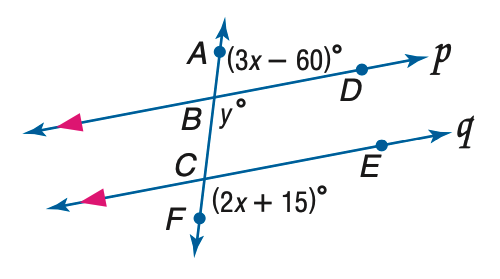Question: Refer to the figure at the right. Find the value of x if p \parallel q.
Choices:
A. 27
B. 45
C. 60
D. 75
Answer with the letter. Answer: B Question: Refer to the figure at the right. Find the value of y if p \parallel q.
Choices:
A. 75
B. 85
C. 95
D. 105
Answer with the letter. Answer: D Question: Refer to the figure at the right. Find the value of m \angle B C E if p \parallel q.
Choices:
A. 75
B. 80
C. 85
D. 605
Answer with the letter. Answer: A Question: Refer to the figure at the right. Find the value of m \angle A B D if p \parallel q.
Choices:
A. 65
B. 70
C. 75
D. 80
Answer with the letter. Answer: C 